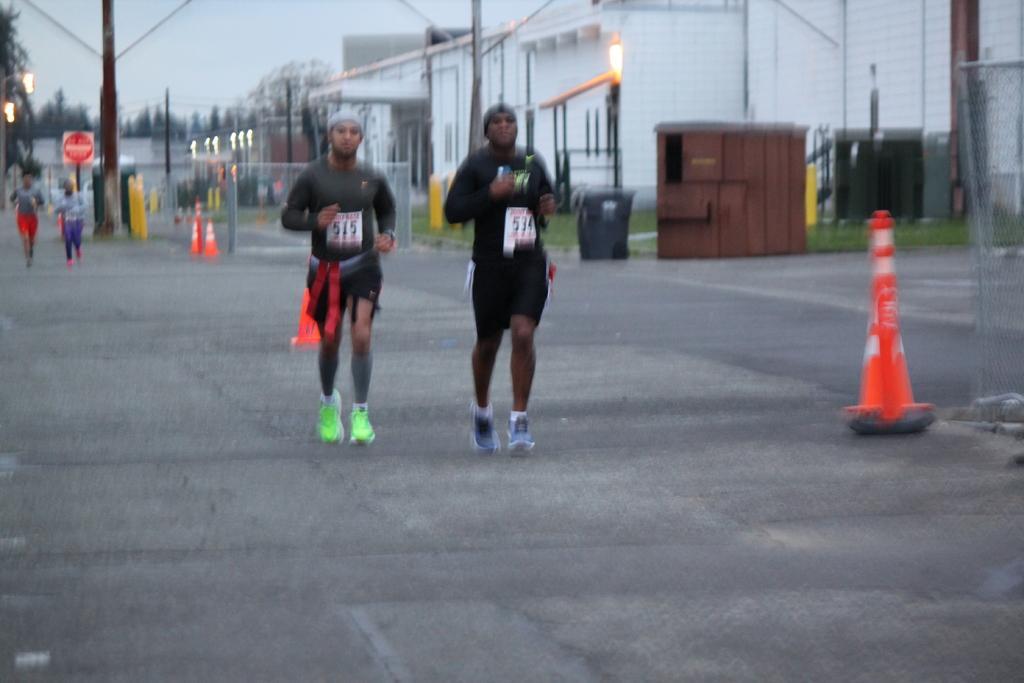Can you describe this image briefly? In this picture we can see group of people, they are running on the road, beside to them we can see few road divider cones, poles and fence, in the background we can see dustbin, few buildings, lights and trees. 